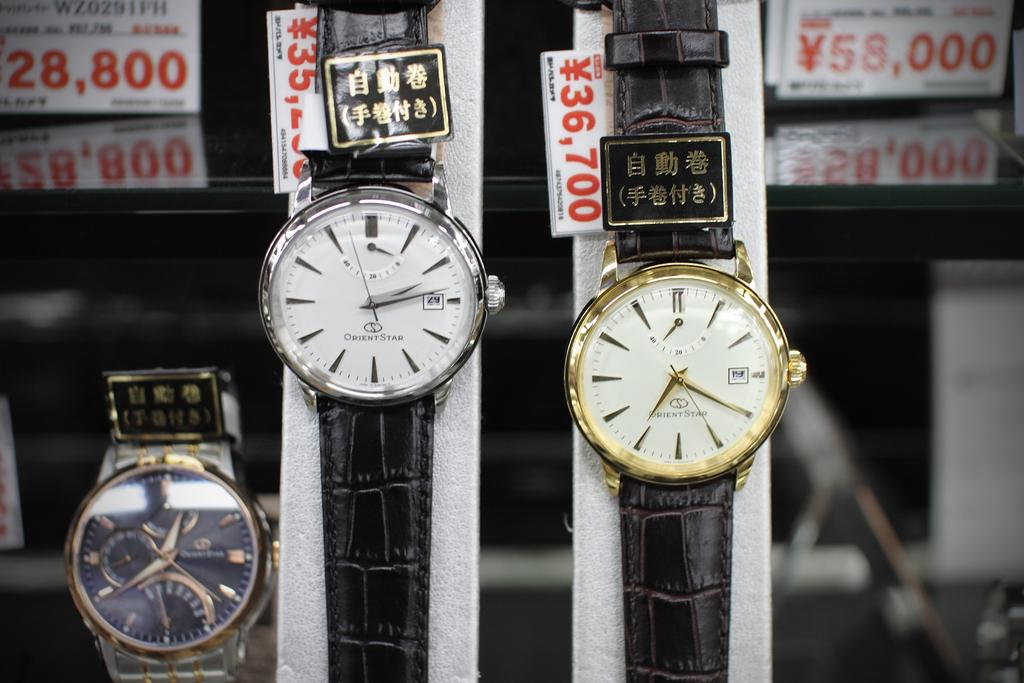<image>
Render a clear and concise summary of the photo. One of the watches in this store display sells for 36,700 yen. 